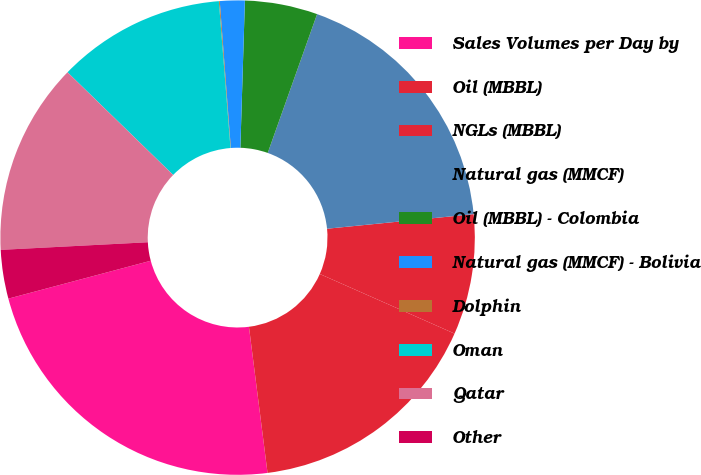<chart> <loc_0><loc_0><loc_500><loc_500><pie_chart><fcel>Sales Volumes per Day by<fcel>Oil (MBBL)<fcel>NGLs (MBBL)<fcel>Natural gas (MMCF)<fcel>Oil (MBBL) - Colombia<fcel>Natural gas (MMCF) - Bolivia<fcel>Dolphin<fcel>Oman<fcel>Qatar<fcel>Other<nl><fcel>22.88%<fcel>16.36%<fcel>8.21%<fcel>17.99%<fcel>4.95%<fcel>1.69%<fcel>0.06%<fcel>11.47%<fcel>13.1%<fcel>3.32%<nl></chart> 